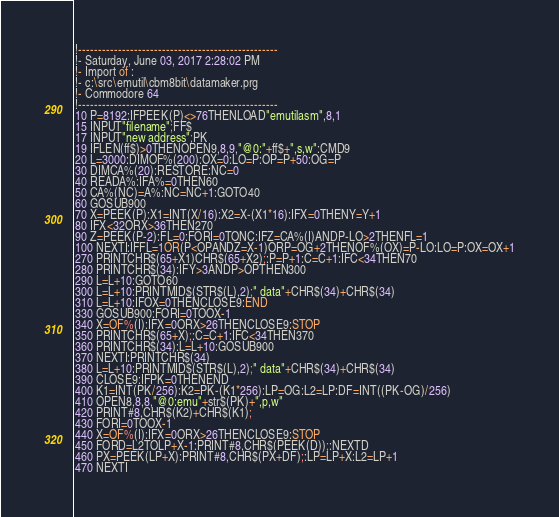Convert code to text. <code><loc_0><loc_0><loc_500><loc_500><_VisualBasic_>!--------------------------------------------------
!- Saturday, June 03, 2017 2:28:02 PM
!- Import of : 
!- c:\src\emutil\cbm8bit\datamaker.prg
!- Commodore 64
!--------------------------------------------------
10 P=8192:IFPEEK(P)<>76THENLOAD"emutilasm",8,1
15 INPUT"filename";FF$
17 INPUT"new address";PK
19 IFLEN(ff$)>0THENOPEN9,8,9,"@0:"+ff$+",s,w":CMD9
20 L=3000:DIMOF%(200):OX=0:LO=P:OP=P+50:OG=P
30 DIMCA%(20):RESTORE:NC=0
40 READA%:IFA%=0THEN60
50 CA%(NC)=A%:NC=NC+1:GOTO40
60 GOSUB900
70 X=PEEK(P):X1=INT(X/16):X2=X-(X1*16):IFX=0THENY=Y+1
80 IFX<32ORX>36THEN270
90 Z=PEEK(P-2):FL=0:FORI=0TONC:IFZ=CA%(I)ANDP-LO>2THENFL=1
100 NEXTI:IFFL=1OR(P<OPANDZ=X-1)ORP=OG+2THENOF%(OX)=P-LO:LO=P:OX=OX+1
270 PRINTCHR$(65+X1)CHR$(65+X2);:P=P+1:C=C+1:IFC<34THEN70
280 PRINTCHR$(34):IFY>3ANDP>OPTHEN300
290 L=L+10:GOTO60
300 L=L+10:PRINTMID$(STR$(L),2);" data"+CHR$(34)+CHR$(34)
310 L=L+10:IFOX=0THENCLOSE9:END
330 GOSUB900:FORI=0TOOX-1
340 X=OF%(I):IFX=0ORX>26THENCLOSE9:STOP
350 PRINTCHR$(65+X);:C=C+1:IFC<34THEN370
360 PRINTCHR$(34):L=L+10:GOSUB900
370 NEXTI:PRINTCHR$(34)
380 L=L+10:PRINTMID$(STR$(L),2);" data"+CHR$(34)+CHR$(34)
390 CLOSE9:IFPK=0THENEND
400 K1=INT(PK/256):K2=PK-(K1*256):LP=OG:L2=LP:DF=INT((PK-OG)/256)
410 OPEN8,8,8,"@0:emu"+str$(PK)+",p,w"
420 PRINT#8,CHR$(K2)+CHR$(K1);
430 FORI=0TOOX-1
440 X=OF%(I):IFX=0ORX>26THENCLOSE9:STOP
450 FORD=L2TOLP+X-1:PRINT#8,CHR$(PEEK(D));:NEXTD
460 PX=PEEK(LP+X):PRINT#8,CHR$(PX+DF);:LP=LP+X:L2=LP+1
470 NEXTI</code> 